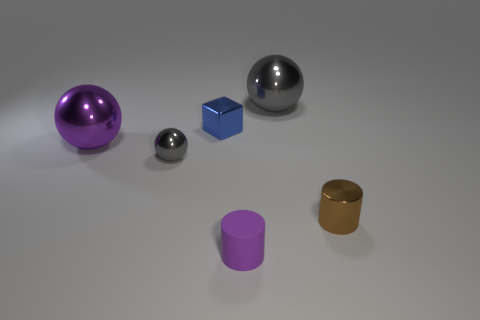There is a gray thing in front of the shiny ball on the right side of the thing that is in front of the tiny brown cylinder; what shape is it?
Make the answer very short. Sphere. What is the material of the small object that is both left of the large gray thing and right of the tiny blue shiny object?
Provide a succinct answer. Rubber. What is the shape of the large thing left of the cylinder in front of the brown object?
Make the answer very short. Sphere. Is there anything else of the same color as the matte cylinder?
Offer a very short reply. Yes. Do the purple matte thing and the gray ball that is behind the purple metal object have the same size?
Make the answer very short. No. How many big things are either green metal things or brown cylinders?
Offer a terse response. 0. Are there more brown cylinders than big purple cubes?
Give a very brief answer. Yes. How many small shiny things are right of the gray sphere that is left of the large metal ball right of the rubber cylinder?
Give a very brief answer. 2. There is a blue metallic thing; what shape is it?
Offer a very short reply. Cube. How many other things are the same material as the blue block?
Your response must be concise. 4. 